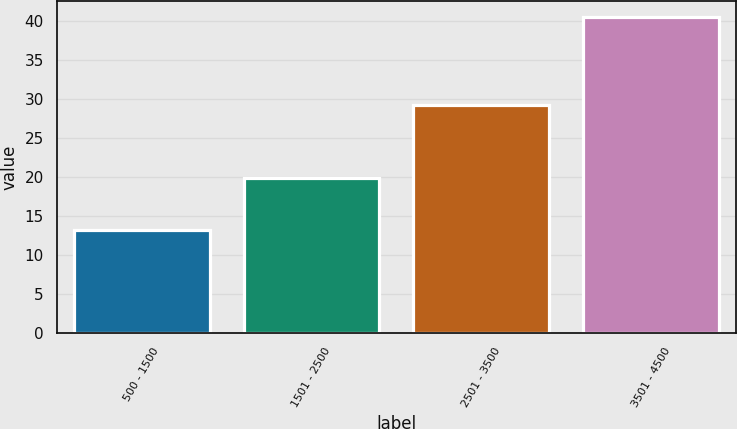Convert chart to OTSL. <chart><loc_0><loc_0><loc_500><loc_500><bar_chart><fcel>500 - 1500<fcel>1501 - 2500<fcel>2501 - 3500<fcel>3501 - 4500<nl><fcel>13.17<fcel>19.94<fcel>29.24<fcel>40.62<nl></chart> 